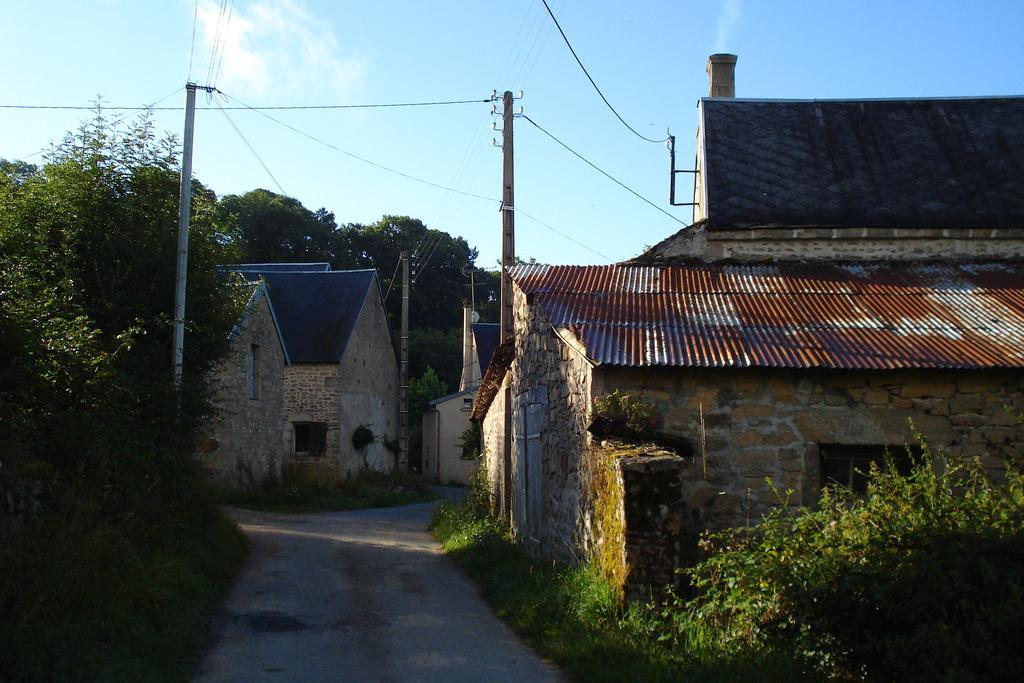Please provide a concise description of this image. In this image we can see few houses. There are few electrical poles and many cables connected to it. There is the sky in the image. There are many trees and plants in the image. There is a road in the image. 